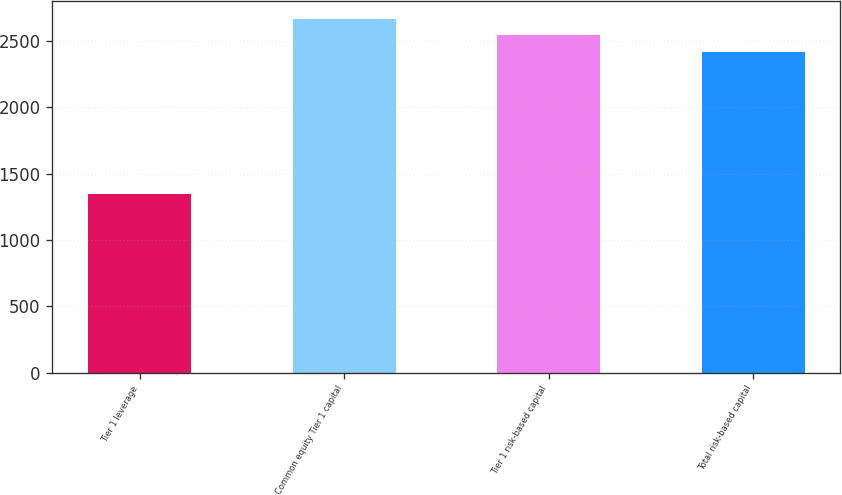Convert chart to OTSL. <chart><loc_0><loc_0><loc_500><loc_500><bar_chart><fcel>Tier 1 leverage<fcel>Common equity Tier 1 capital<fcel>Tier 1 risk-based capital<fcel>Total risk-based capital<nl><fcel>1346<fcel>2668.8<fcel>2543.4<fcel>2418<nl></chart> 